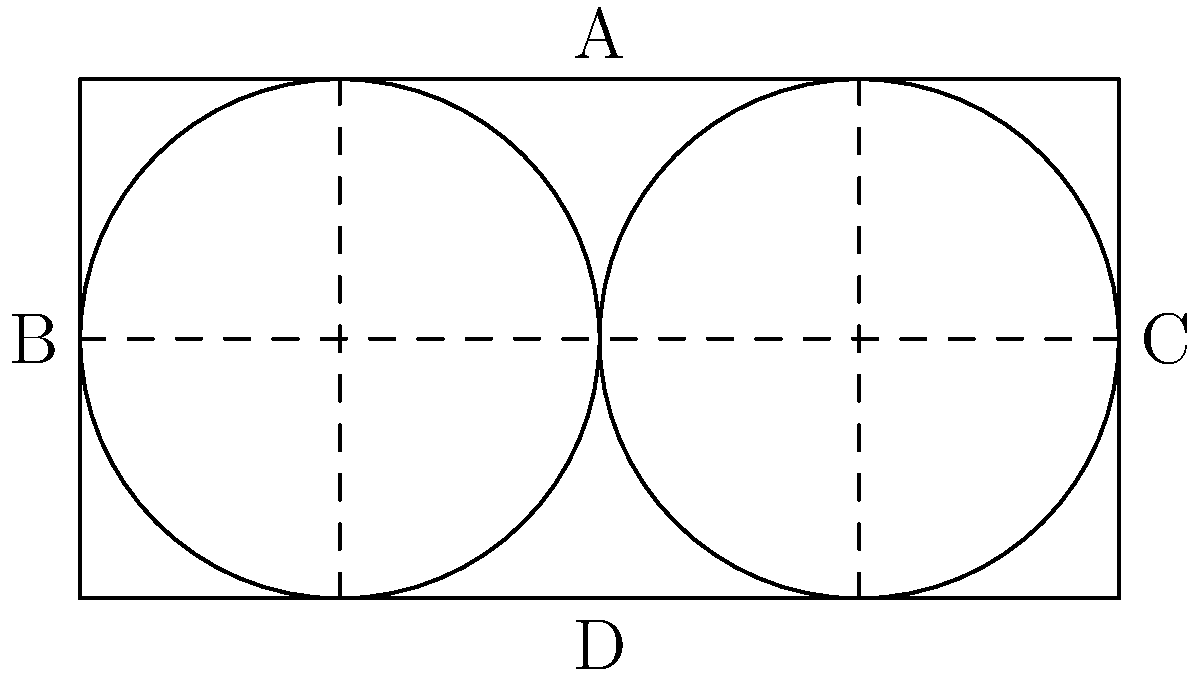Given the rectangular wooden block ABCD with dimensions 10 cm x 5 cm, what is the maximum number of circular clog soles with a diameter of 5 cm that can be cut from this block while minimizing wood waste? Provide the optimal cutting pattern and calculate the wood utilization efficiency as a percentage. To solve this problem, we'll follow these steps:

1. Analyze the given dimensions:
   - Rectangle: 10 cm x 5 cm
   - Circular sole diameter: 5 cm (radius = 2.5 cm)

2. Determine the maximum number of circular soles:
   - The height of the rectangle (5 cm) exactly matches the diameter of the circular sole.
   - We can fit two circles along the length of the rectangle (10 cm ÷ 5 cm = 2).

3. Calculate the areas:
   - Rectangle area: $A_r = 10 \text{ cm} \times 5 \text{ cm} = 50 \text{ cm}^2$
   - Circle area: $A_c = \pi r^2 = \pi (2.5 \text{ cm})^2 = 19.63 \text{ cm}^2$

4. Calculate the total area of the two circular soles:
   $A_{\text{total circles}} = 2 \times 19.63 \text{ cm}^2 = 39.27 \text{ cm}^2$

5. Calculate the wood utilization efficiency:
   Efficiency = $\frac{\text{Area of circular soles}}{\text{Area of rectangular block}} \times 100\%$
   
   $\text{Efficiency} = \frac{39.27 \text{ cm}^2}{50 \text{ cm}^2} \times 100\% = 78.54\%$

The optimal cutting pattern is shown in the diagram, with two circular soles placed side by side in the rectangular block.
Answer: 2 soles; 78.54% efficiency 